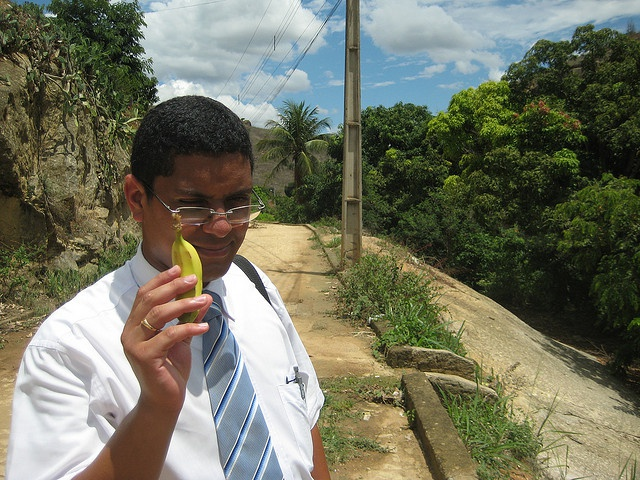Describe the objects in this image and their specific colors. I can see people in olive, white, maroon, black, and darkgray tones, tie in olive, darkgray, gray, and white tones, and banana in olive and khaki tones in this image. 